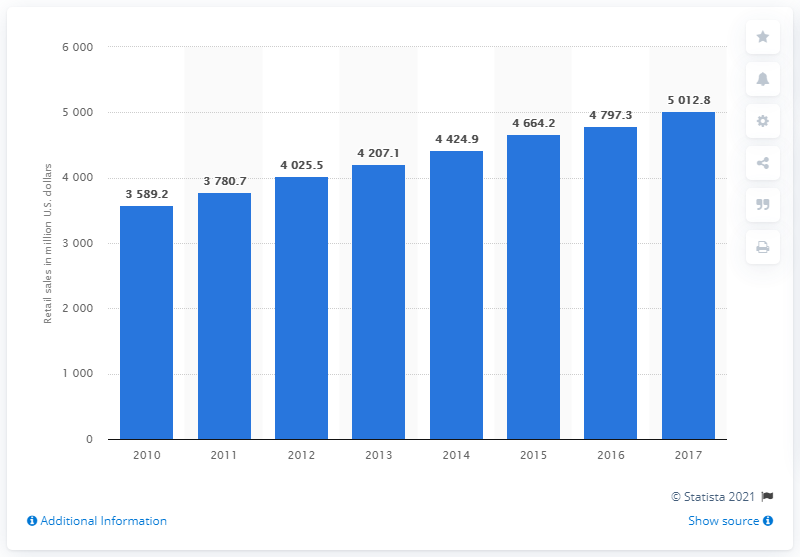Give some essential details in this illustration. In 2017, the U.S. contact lens market generated a total of $50.128 billion in retail sales. 